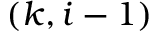Convert formula to latex. <formula><loc_0><loc_0><loc_500><loc_500>( k , i - 1 )</formula> 